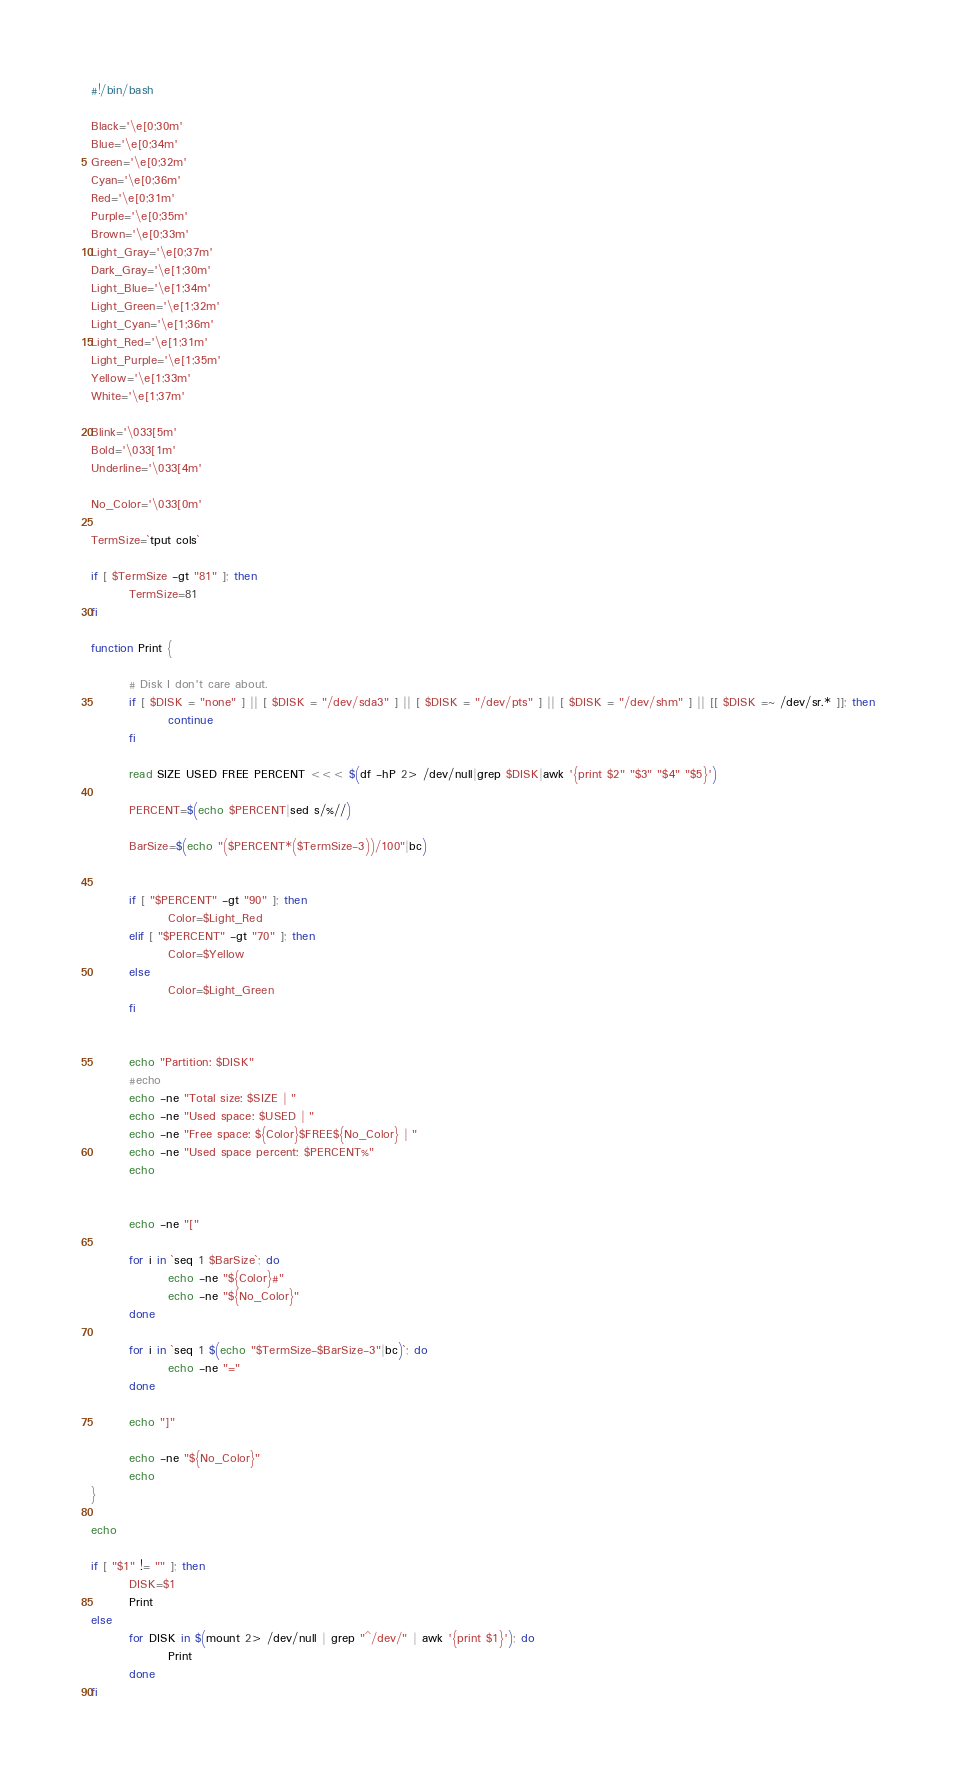<code> <loc_0><loc_0><loc_500><loc_500><_Bash_>#!/bin/bash

Black='\e[0;30m'
Blue='\e[0;34m'
Green='\e[0;32m'
Cyan='\e[0;36m'
Red='\e[0;31m'
Purple='\e[0;35m'
Brown='\e[0;33m'
Light_Gray='\e[0;37m'
Dark_Gray='\e[1;30m'
Light_Blue='\e[1;34m'
Light_Green='\e[1;32m'
Light_Cyan='\e[1;36m'
Light_Red='\e[1;31m'
Light_Purple='\e[1;35m'
Yellow='\e[1;33m'
White='\e[1;37m'

Blink='\033[5m'
Bold='\033[1m'
Underline='\033[4m'

No_Color='\033[0m'

TermSize=`tput cols`

if [ $TermSize -gt "81" ]; then
        TermSize=81
fi

function Print {
        
        # Disk I don't care about.
        if [ $DISK = "none" ] || [ $DISK = "/dev/sda3" ] || [ $DISK = "/dev/pts" ] || [ $DISK = "/dev/shm" ] || [[ $DISK =~ /dev/sr.* ]]; then
                continue
        fi

        read SIZE USED FREE PERCENT <<< $(df -hP 2> /dev/null|grep $DISK|awk '{print $2" "$3" "$4" "$5}')
        
        PERCENT=$(echo $PERCENT|sed s/%//)
        
        BarSize=$(echo "($PERCENT*($TermSize-3))/100"|bc)


        if [ "$PERCENT" -gt "90" ]; then
                Color=$Light_Red
        elif [ "$PERCENT" -gt "70" ]; then
                Color=$Yellow
        else
                Color=$Light_Green
        fi

        
        echo "Partition: $DISK"
        #echo
        echo -ne "Total size: $SIZE | "
        echo -ne "Used space: $USED | "
        echo -ne "Free space: ${Color}$FREE${No_Color} | "
        echo -ne "Used space percent: $PERCENT%"
        echo
        

        echo -ne "["
        
        for i in `seq 1 $BarSize`; do
                echo -ne "${Color}#"
                echo -ne "${No_Color}"
        done

        for i in `seq 1 $(echo "$TermSize-$BarSize-3"|bc)`; do
                echo -ne "="
        done

        echo "]"

        echo -ne "${No_Color}"
        echo
}

echo

if [ "$1" != "" ]; then
        DISK=$1
        Print
else
        for DISK in $(mount 2> /dev/null | grep "^/dev/" | awk '{print $1}'); do
                Print
        done
fi
</code> 